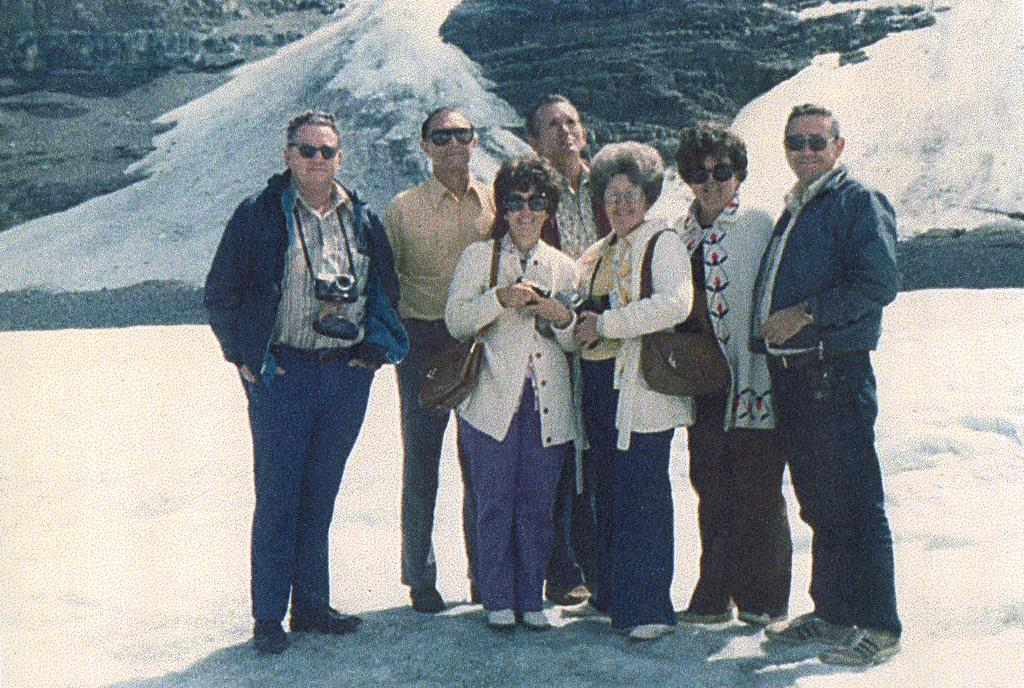What is the main subject of the image? There is a person standing in the center of the image. What is the person standing on? The person is standing on snow. What can be seen in the background of the image? There is snow and a mountain visible in the background of the image. What type of doll can be heard talking in the image? There is no doll present in the image, and therefore no voice can be heard. 